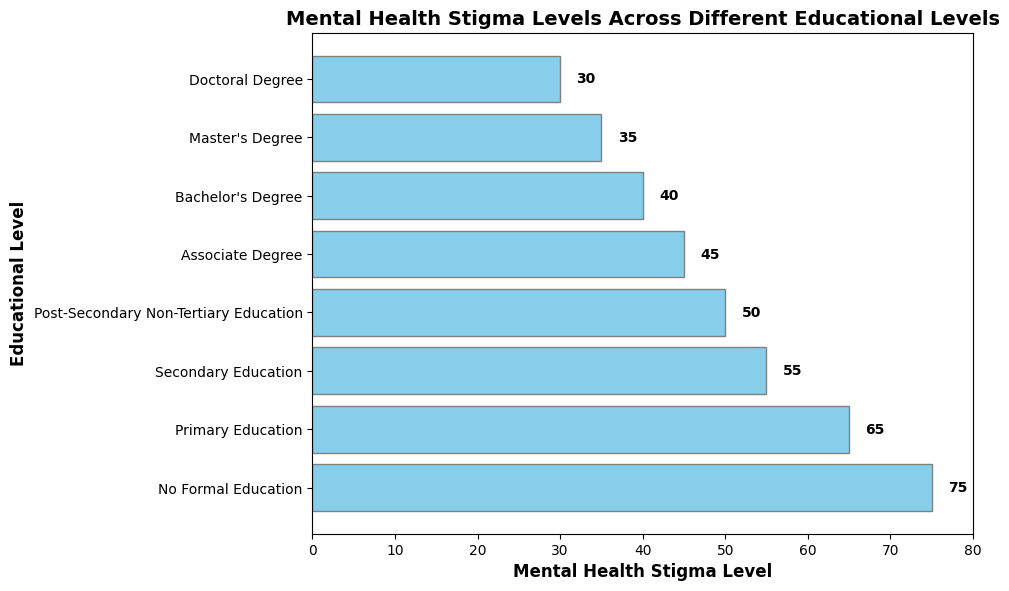What educational level has the highest mental health stigma level? By looking at the length of the bars, the bar representing 'No Formal Education' is the longest, indicating the highest mental health stigma level.
Answer: No Formal Education Which educational level has the lowest mental health stigma level? By observing the bar lengths, the 'Doctoral Degree' bar is the shortest, indicating the lowest mental health stigma level.
Answer: Doctoral Degree What is the difference in mental health stigma levels between individuals with a Primary Education and a Bachelor's Degree? Looking at the stigma levels, Primary Education has 65 and Bachelor's Degree has 40. The difference is calculated as 65 - 40.
Answer: 25 Calculate the average mental health stigma level across all educational levels. Add up all the stigma levels and divide by the number of educational levels: (75 + 65 + 55 + 50 + 45 + 40 + 35 + 30) / 8 = 395 / 8.
Answer: 49.375 Which two educational levels have the smallest difference in mental health stigma levels, and what is that difference? Comparing the stigma levels, Post-Secondary Non-Tertiary Education (50) and Associate Degree (45) are closest. The difference is 50 - 45.
Answer: 5 How much higher is the stigma level for those with No Formal Education compared to those with a Master's Degree? No Formal Education has a stigma level of 75, and Master's Degree has 35. The difference is calculated as 75 - 35.
Answer: 40 Is the stigma level of Secondary Education closer to Primary Education or Post-Secondary Non-Tertiary Education? Secondary Education has a stigma level of 55. Primary Education is 65, and Post-Secondary Non-Tertiary Education is 50. Differences are 65 - 55 = 10 and 55 - 50 = 5.
Answer: Post-Secondary Non-Tertiary Education By how much does the stigma level decrease on average with each higher level of education, from No Formal Education to Doctoral Degree? Calculate the total decrease and divide by the number of steps: (75 - 30) / (8 - 1) = 45 / 7.
Answer: 6.43 Are there any educational levels where the stigma levels are equal? By checking the bars' lengths, there are no educational levels with equal stigma levels.
Answer: No How does the stigma level for those with a Master's Degree compare to those with a Doctoral Degree? Master's Degree has a stigma level of 35, while Doctoral Degree has 30. The stigma level for Master's Degree is higher than Doctoral Degree.
Answer: Higher 